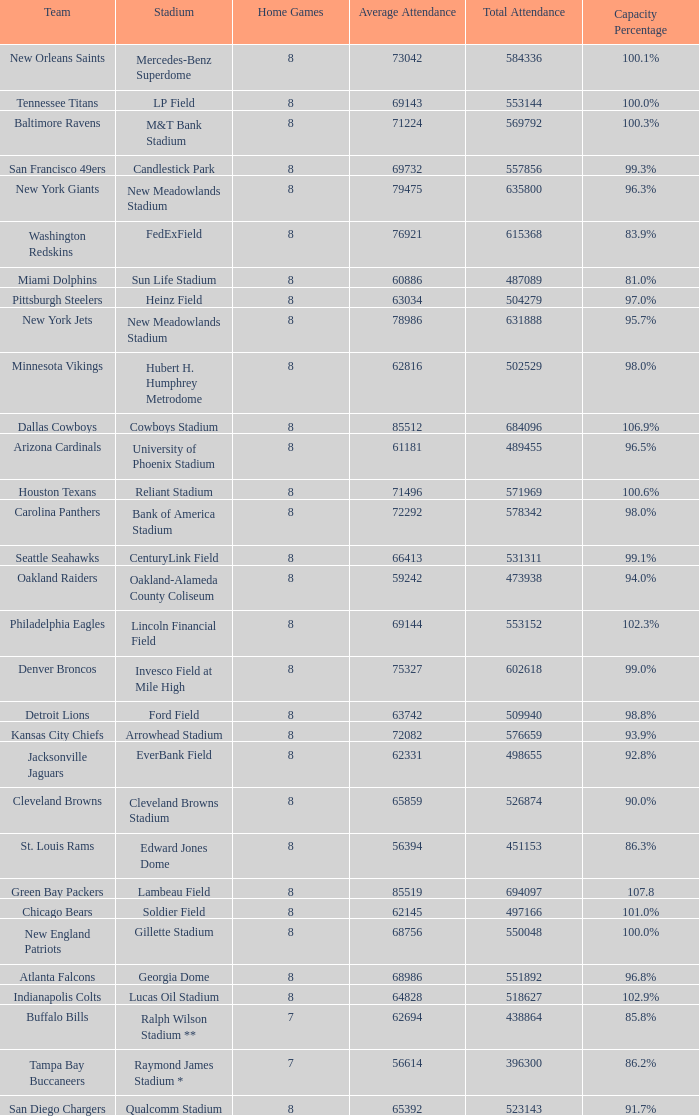How many average attendance has a capacity percentage of 96.5% 1.0. 